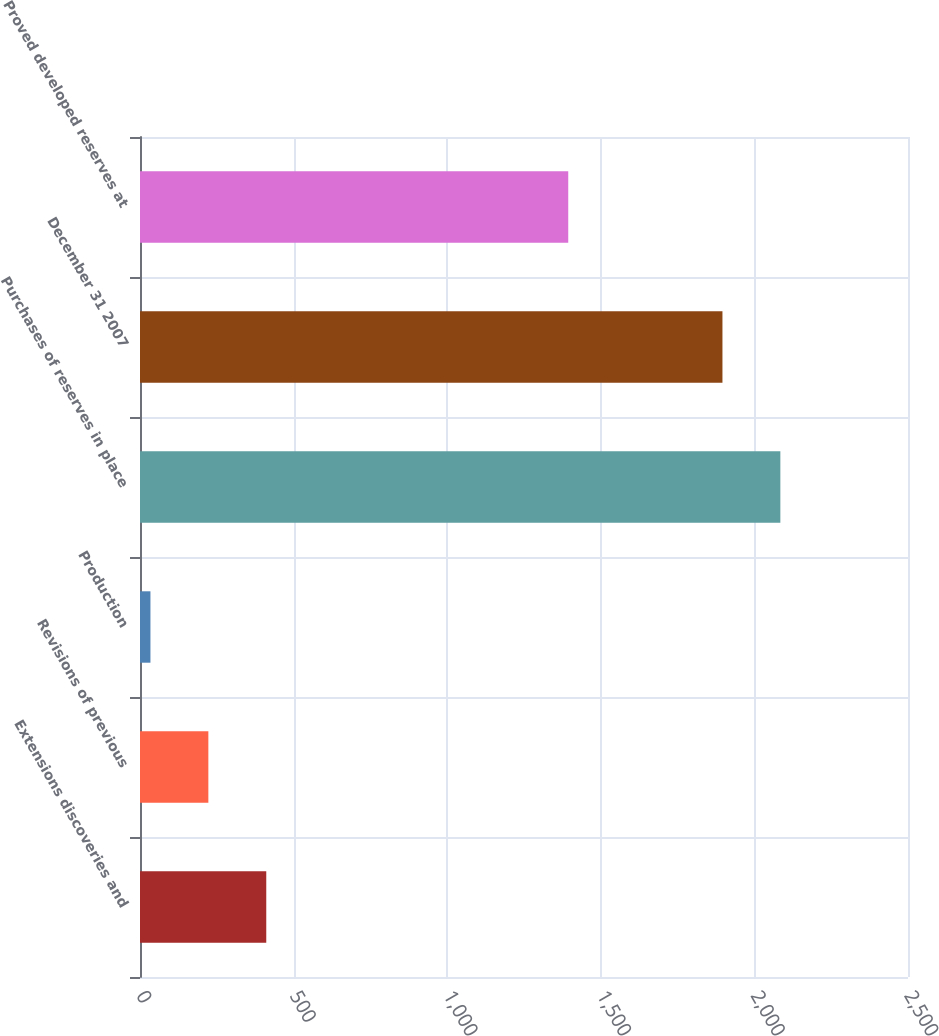<chart> <loc_0><loc_0><loc_500><loc_500><bar_chart><fcel>Extensions discoveries and<fcel>Revisions of previous<fcel>Production<fcel>Purchases of reserves in place<fcel>December 31 2007<fcel>Proved developed reserves at<nl><fcel>411<fcel>222.5<fcel>34<fcel>2084.5<fcel>1896<fcel>1394<nl></chart> 